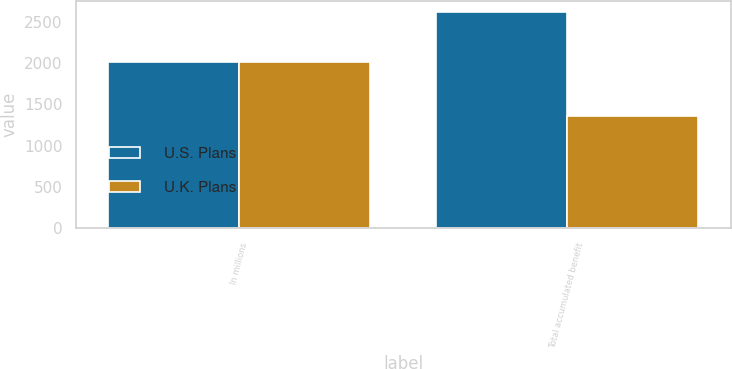Convert chart. <chart><loc_0><loc_0><loc_500><loc_500><stacked_bar_chart><ecel><fcel>In millions<fcel>Total accumulated benefit<nl><fcel>U.S. Plans<fcel>2016<fcel>2625<nl><fcel>U.K. Plans<fcel>2016<fcel>1366<nl></chart> 